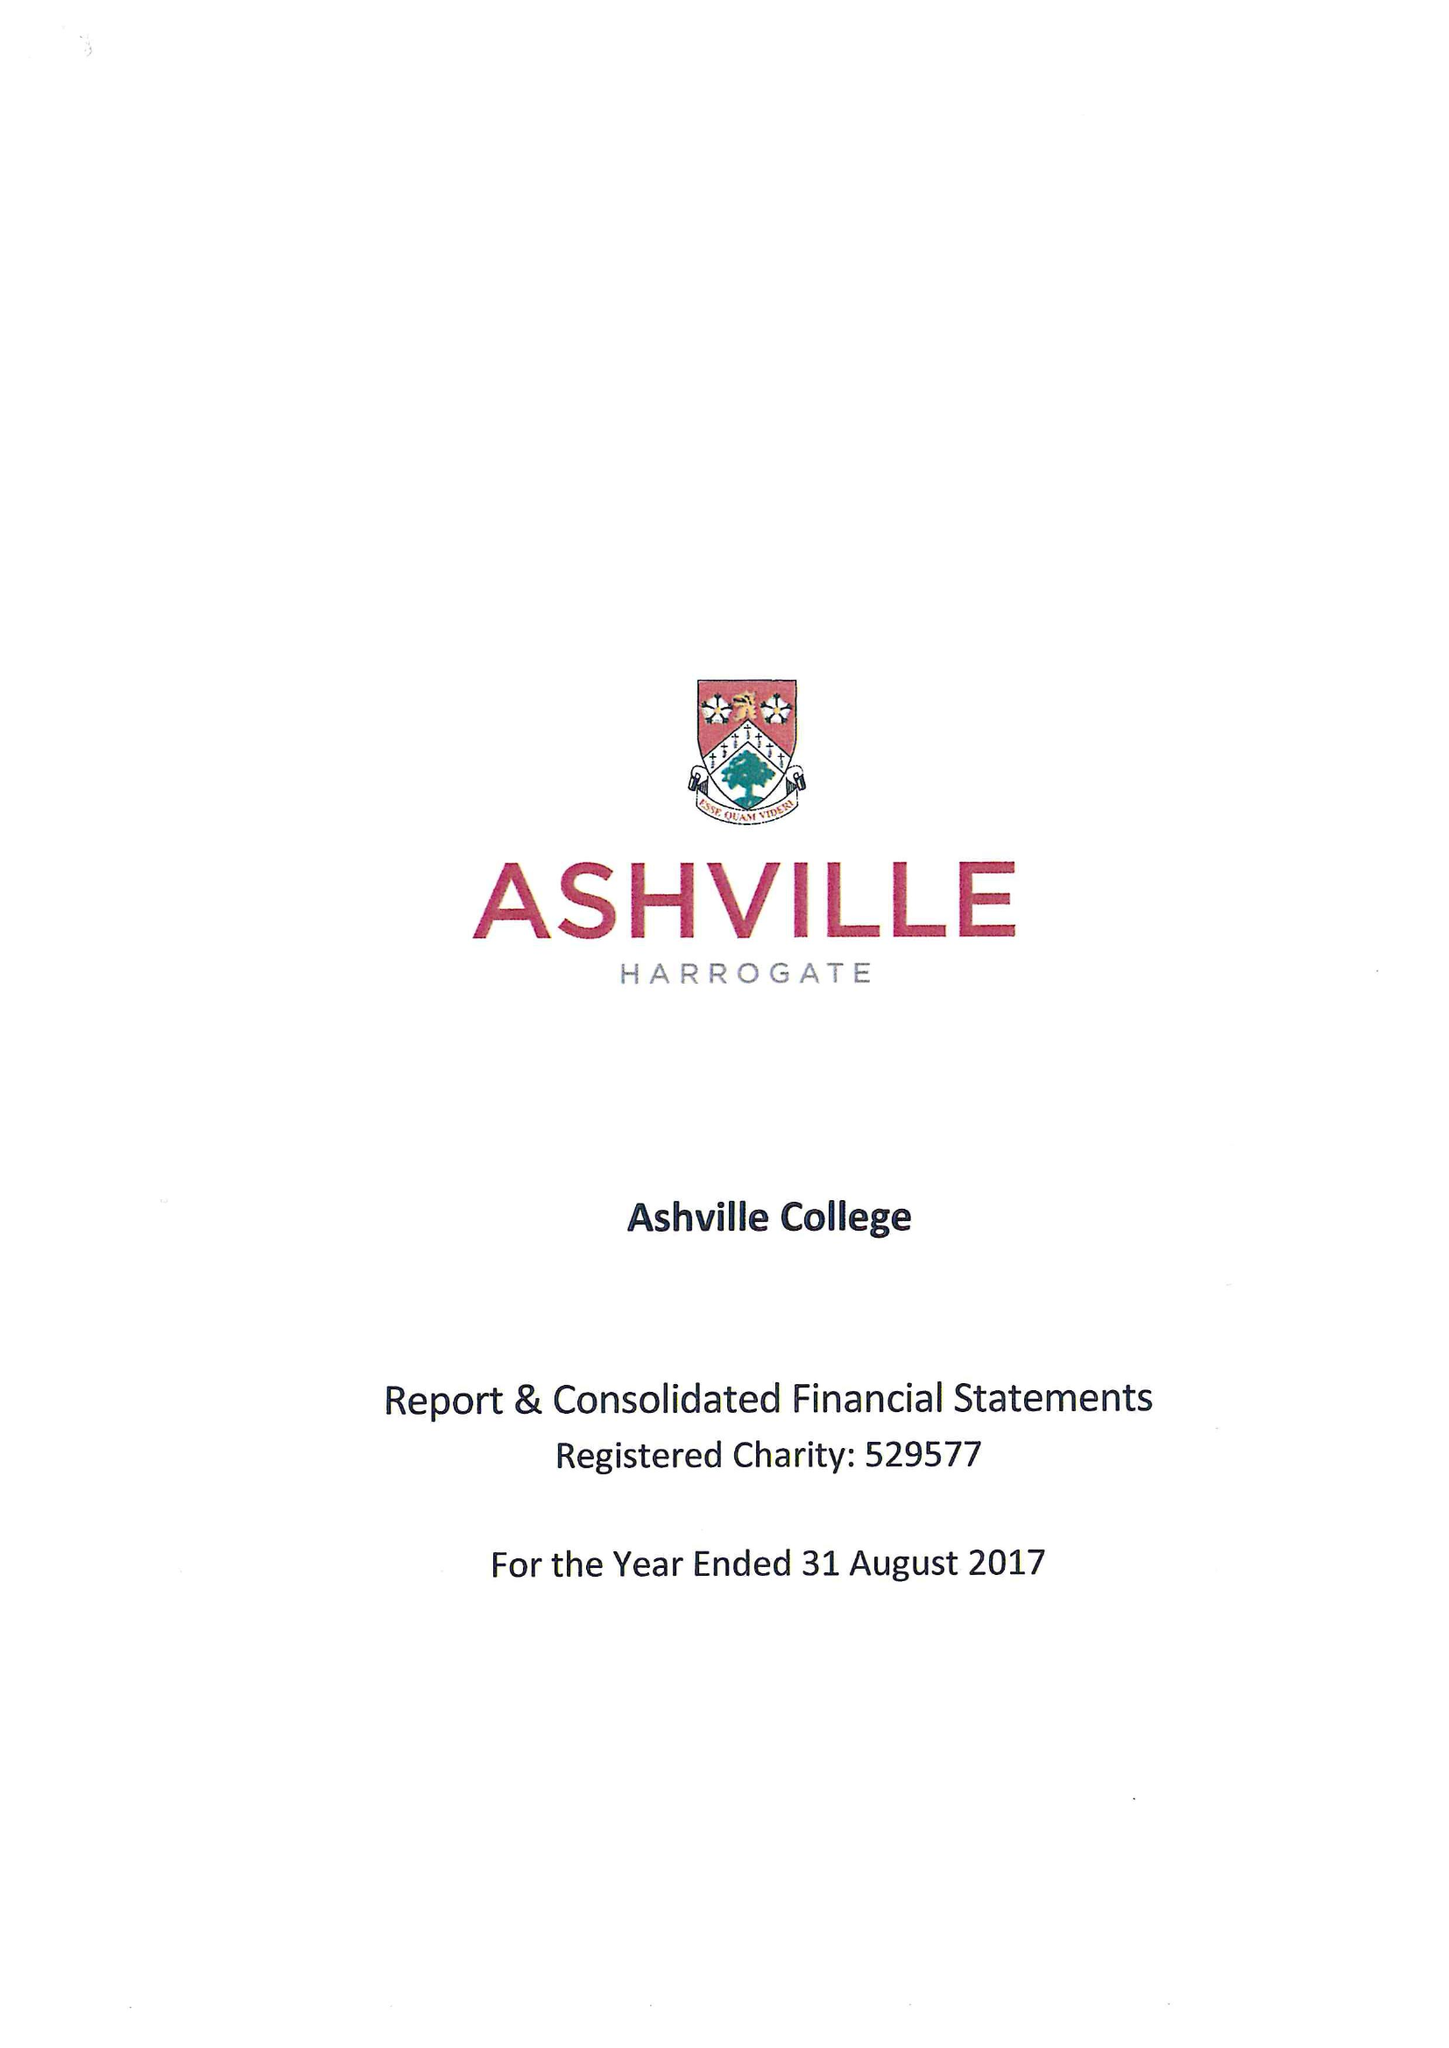What is the value for the spending_annually_in_british_pounds?
Answer the question using a single word or phrase. 11808695.00 